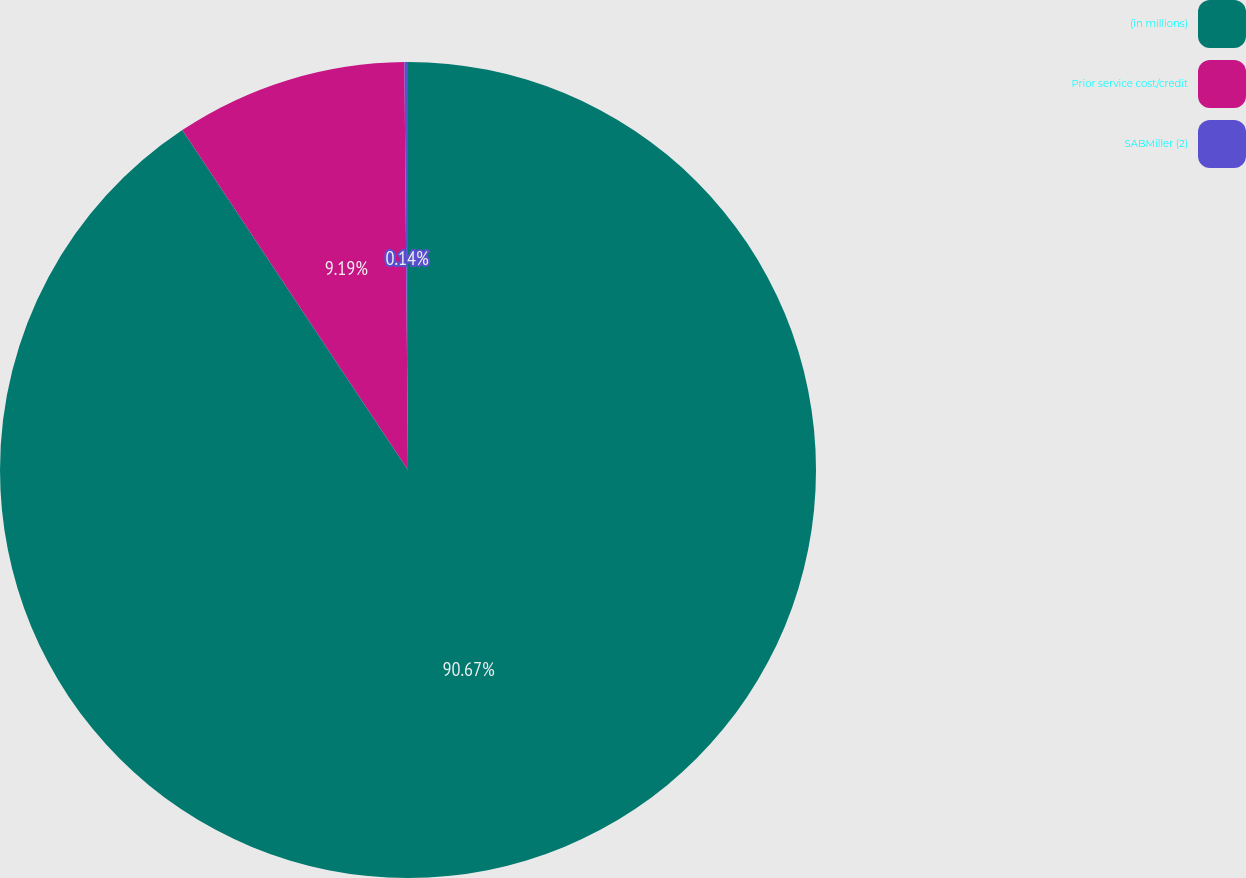Convert chart to OTSL. <chart><loc_0><loc_0><loc_500><loc_500><pie_chart><fcel>(in millions)<fcel>Prior service cost/credit<fcel>SABMiller (2)<nl><fcel>90.68%<fcel>9.19%<fcel>0.14%<nl></chart> 